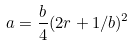<formula> <loc_0><loc_0><loc_500><loc_500>a = \frac { b } { 4 } ( 2 r + 1 / b ) ^ { 2 }</formula> 